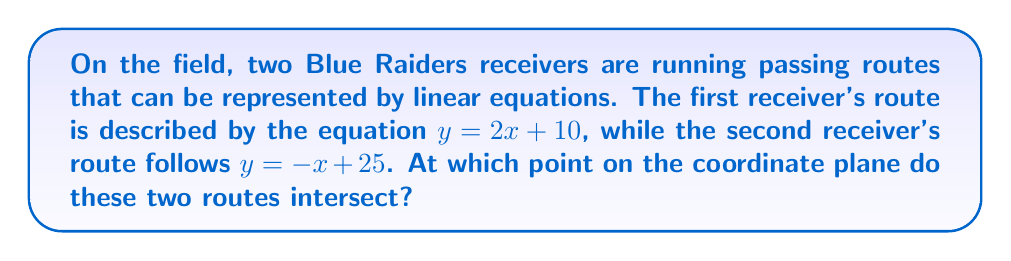Solve this math problem. To find the intersection point of these two passing routes, we need to solve the system of equations:

$$\begin{cases}
y = 2x + 10 \\
y = -x + 25
\end{cases}$$

Step 1: Since both equations are equal to y, we can set them equal to each other:
$2x + 10 = -x + 25$

Step 2: Add x to both sides of the equation:
$3x + 10 = 25$

Step 3: Subtract 10 from both sides:
$3x = 15$

Step 4: Divide both sides by 3:
$x = 5$

Step 5: Substitute this x-value into either of the original equations. Let's use $y = 2x + 10$:
$y = 2(5) + 10 = 10 + 10 = 20$

Therefore, the intersection point is (5, 20).

[asy]
unitsize(0.5cm);
draw((-2,0)--(12,0),arrow=Arrow(TeXHead));
draw((0,-2)--(0,30),arrow=Arrow(TeXHead));
for(int i=-2; i<=12; ++i) {
  draw((i,-0.1)--(i,0.1));
  if(i%5==0 && i!=0) label("$" + string(i) + "$",(i,-0.5),S);
}
for(int i=0; i<=30; i+=5) {
  draw((-0.1,i)--(0.1,i));
  if(i>0) label("$" + string(i) + "$",(-0.5,i),W);
}
draw((-2,6)--(12,34),blue);
draw((-2,27)--(12,13),red);
dot((5,20),filltype=FillDraw(black,white));
label("(5, 20)",(5,20),NE);
label("$y=2x+10$",(10,30),E,blue);
label("$y=-x+25$",(10,15),E,red);
[/asy]
Answer: (5, 20) 